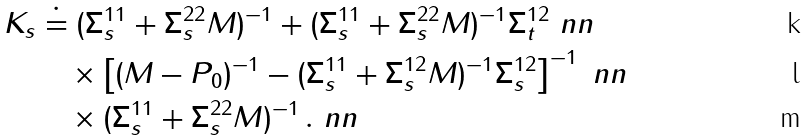Convert formula to latex. <formula><loc_0><loc_0><loc_500><loc_500>K _ { s } & \doteq ( \Sigma _ { s } ^ { 1 1 } + \Sigma _ { s } ^ { 2 2 } M ) ^ { - 1 } + ( \Sigma _ { s } ^ { 1 1 } + \Sigma _ { s } ^ { 2 2 } M ) ^ { - 1 } \Sigma _ { t } ^ { 1 2 } \ n n \\ & \quad \times \left [ ( M - P _ { 0 } ) ^ { - 1 } - ( \Sigma _ { s } ^ { 1 1 } + \Sigma _ { s } ^ { 1 2 } M ) ^ { - 1 } \Sigma _ { s } ^ { 1 2 } \right ] ^ { - 1 } \ n n \\ & \quad \times ( \Sigma _ { s } ^ { 1 1 } + \Sigma _ { s } ^ { 2 2 } M ) ^ { - 1 } \, . \ n n</formula> 